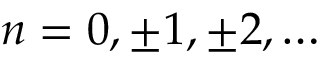<formula> <loc_0><loc_0><loc_500><loc_500>n = 0 , \pm 1 , \pm 2 , \dots</formula> 